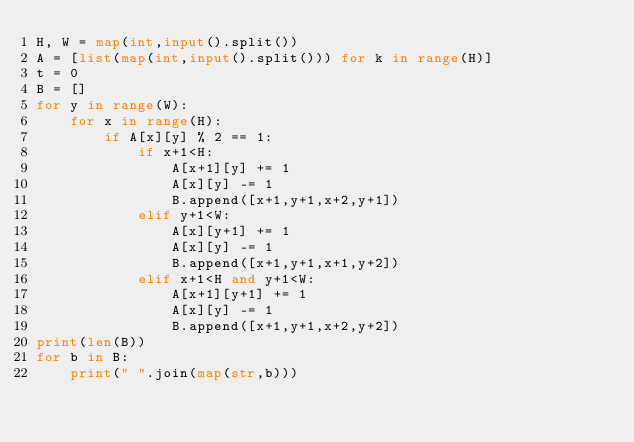<code> <loc_0><loc_0><loc_500><loc_500><_Python_>H, W = map(int,input().split())
A = [list(map(int,input().split())) for k in range(H)]
t = 0
B = []
for y in range(W):
    for x in range(H):
        if A[x][y] % 2 == 1:
            if x+1<H:
                A[x+1][y] += 1
                A[x][y] -= 1
                B.append([x+1,y+1,x+2,y+1])
            elif y+1<W:
                A[x][y+1] += 1
                A[x][y] -= 1
                B.append([x+1,y+1,x+1,y+2])
            elif x+1<H and y+1<W:
                A[x+1][y+1] += 1
                A[x][y] -= 1
                B.append([x+1,y+1,x+2,y+2])
print(len(B))
for b in B:
    print(" ".join(map(str,b)))</code> 